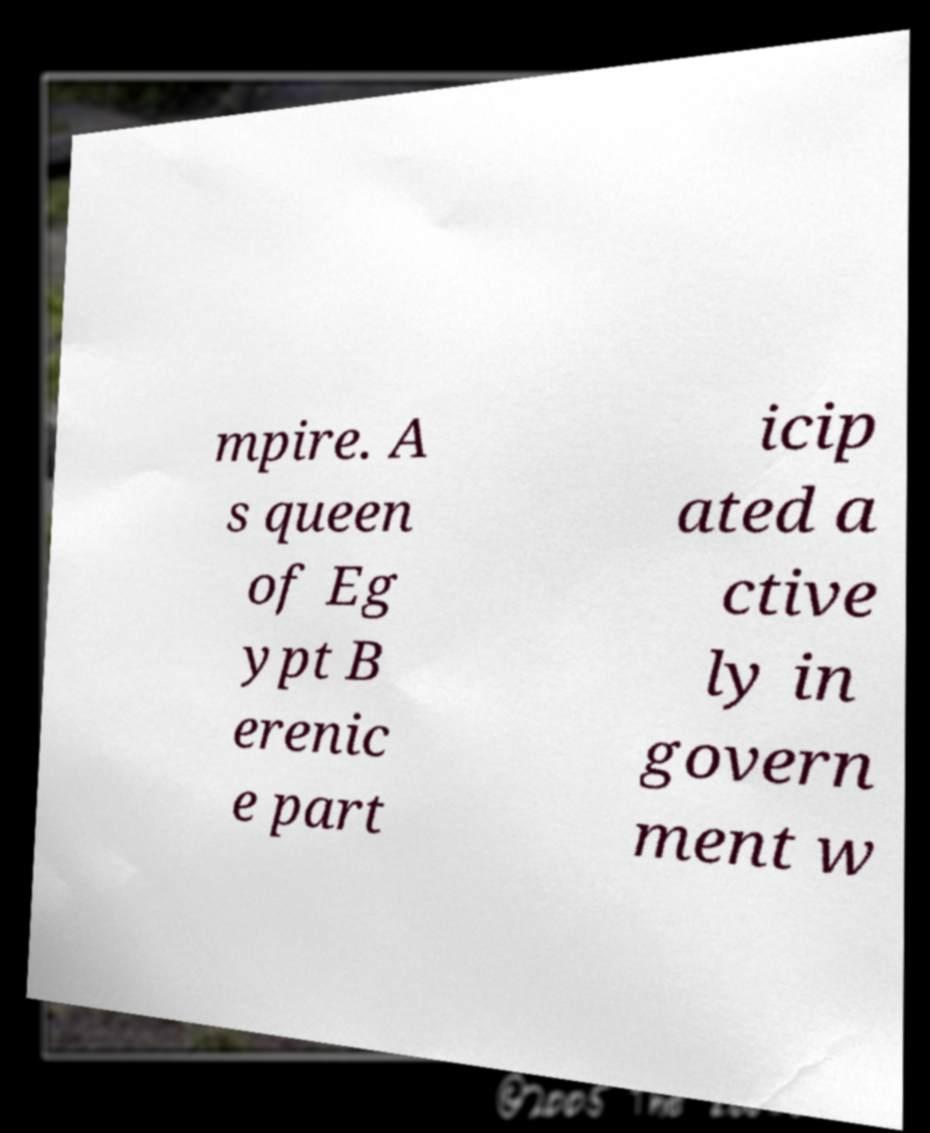Could you extract and type out the text from this image? mpire. A s queen of Eg ypt B erenic e part icip ated a ctive ly in govern ment w 